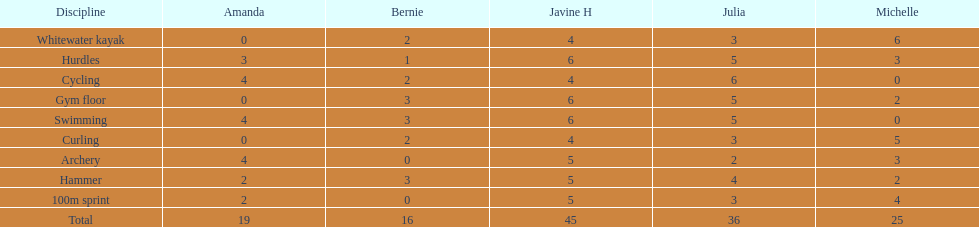Name a girl that had the same score in cycling and archery. Amanda. 